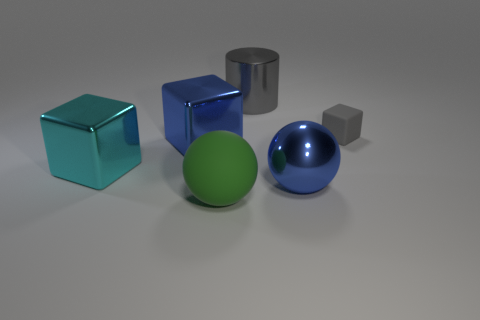Are there any purple matte cylinders?
Provide a short and direct response. No. Is the cyan thing the same shape as the small object?
Offer a very short reply. Yes. The other thing that is the same color as the tiny matte thing is what size?
Give a very brief answer. Large. There is a gray rubber object that is on the right side of the big gray metallic thing; what number of small gray objects are to the left of it?
Provide a short and direct response. 0. What number of rubber objects are both behind the big green matte sphere and in front of the small gray block?
Your response must be concise. 0. How many objects are tiny blue metal things or large objects that are in front of the cyan metallic cube?
Offer a very short reply. 2. The gray cylinder that is the same material as the cyan object is what size?
Provide a short and direct response. Large. What shape is the gray object behind the matte object that is to the right of the large green object?
Make the answer very short. Cylinder. How many purple things are either cylinders or big cubes?
Make the answer very short. 0. There is a ball to the left of the big thing that is right of the gray metallic object; is there a blue metal thing that is to the left of it?
Offer a very short reply. Yes. 